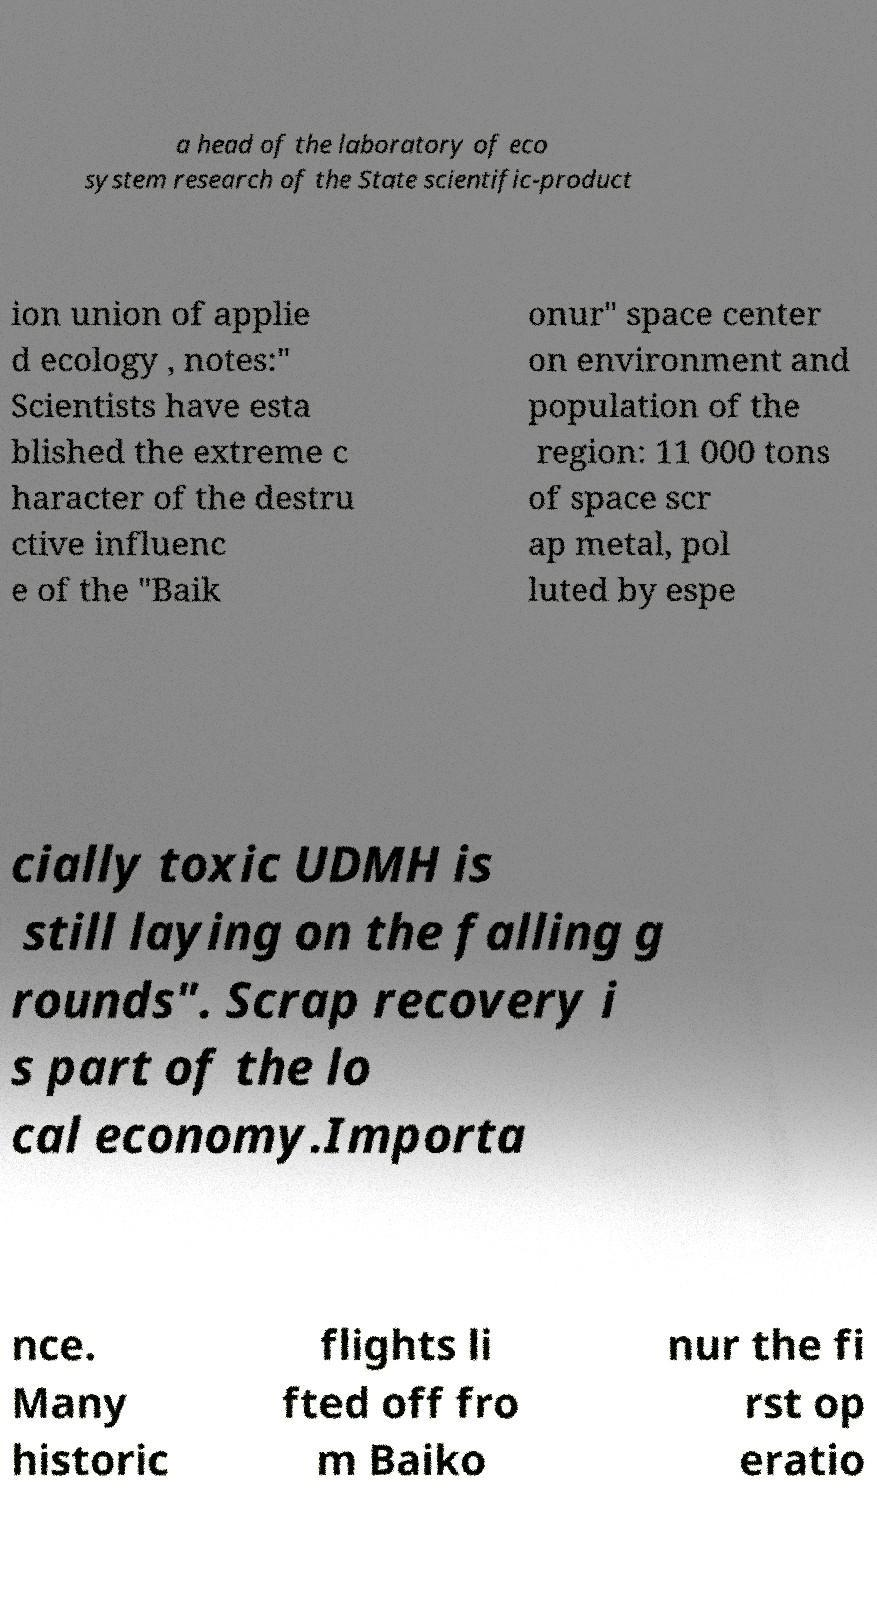Please identify and transcribe the text found in this image. a head of the laboratory of eco system research of the State scientific-product ion union of applie d ecology , notes:" Scientists have esta blished the extreme c haracter of the destru ctive influenc e of the "Baik onur" space center on environment and population of the region: 11 000 tons of space scr ap metal, pol luted by espe cially toxic UDMH is still laying on the falling g rounds". Scrap recovery i s part of the lo cal economy.Importa nce. Many historic flights li fted off fro m Baiko nur the fi rst op eratio 